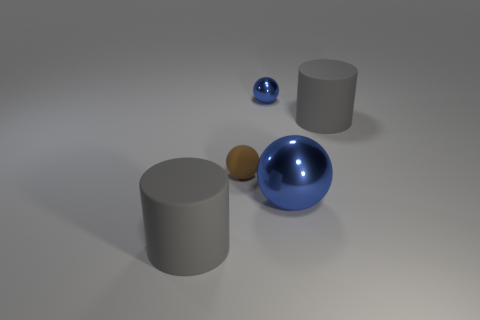Do the small shiny object and the brown object have the same shape?
Offer a very short reply. Yes. Is there any other thing that has the same shape as the tiny blue metallic thing?
Ensure brevity in your answer.  Yes. Do the cylinder in front of the large blue ball and the big rubber cylinder to the right of the tiny rubber sphere have the same color?
Ensure brevity in your answer.  Yes. Are there fewer large metallic balls on the left side of the brown rubber object than cylinders left of the large shiny object?
Make the answer very short. Yes. There is a big blue metal object in front of the brown sphere; what is its shape?
Keep it short and to the point. Sphere. There is a thing that is the same color as the big sphere; what is it made of?
Your answer should be very brief. Metal. How many other things are made of the same material as the big blue sphere?
Make the answer very short. 1. Does the brown object have the same shape as the big object in front of the big metal object?
Keep it short and to the point. No. There is a small thing that is made of the same material as the big blue thing; what shape is it?
Keep it short and to the point. Sphere. Are there more matte things left of the brown ball than rubber cylinders to the right of the large blue ball?
Provide a succinct answer. No. 